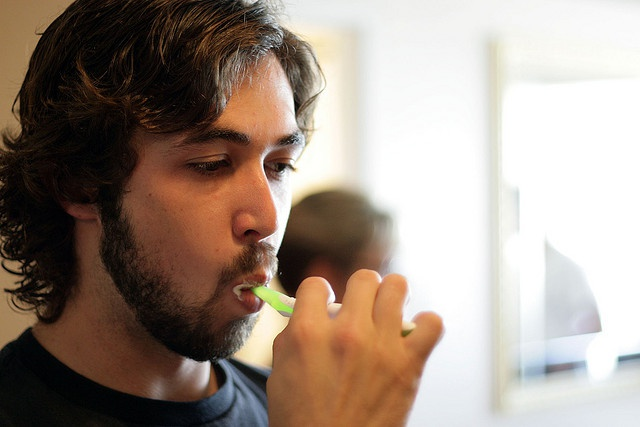Describe the objects in this image and their specific colors. I can see people in olive, black, maroon, brown, and tan tones, people in olive, maroon, black, and darkgray tones, people in olive, lightgray, and darkgray tones, and toothbrush in olive, khaki, lightgreen, and tan tones in this image. 